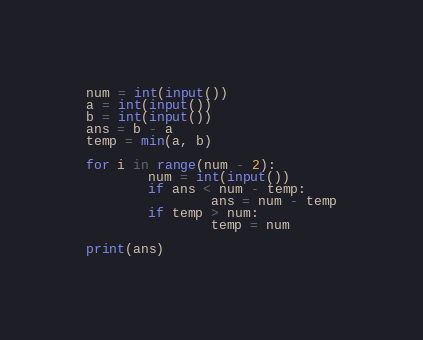<code> <loc_0><loc_0><loc_500><loc_500><_Python_>num = int(input())
a = int(input())
b = int(input())
ans = b - a
temp = min(a, b)

for i in range(num - 2):
        num = int(input())
        if ans < num - temp:
                ans = num - temp
        if temp > num:
                temp = num

print(ans)
</code> 